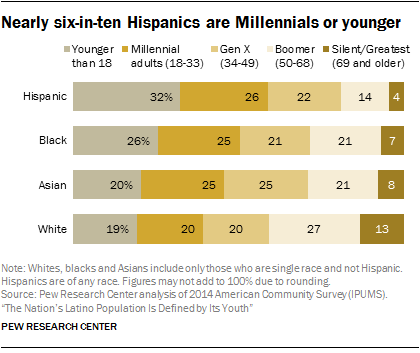Draw attention to some important aspects in this diagram. The sum of Hispanics and Blacks younger than 18 in the chart is 58. There are five colors in the bar. 